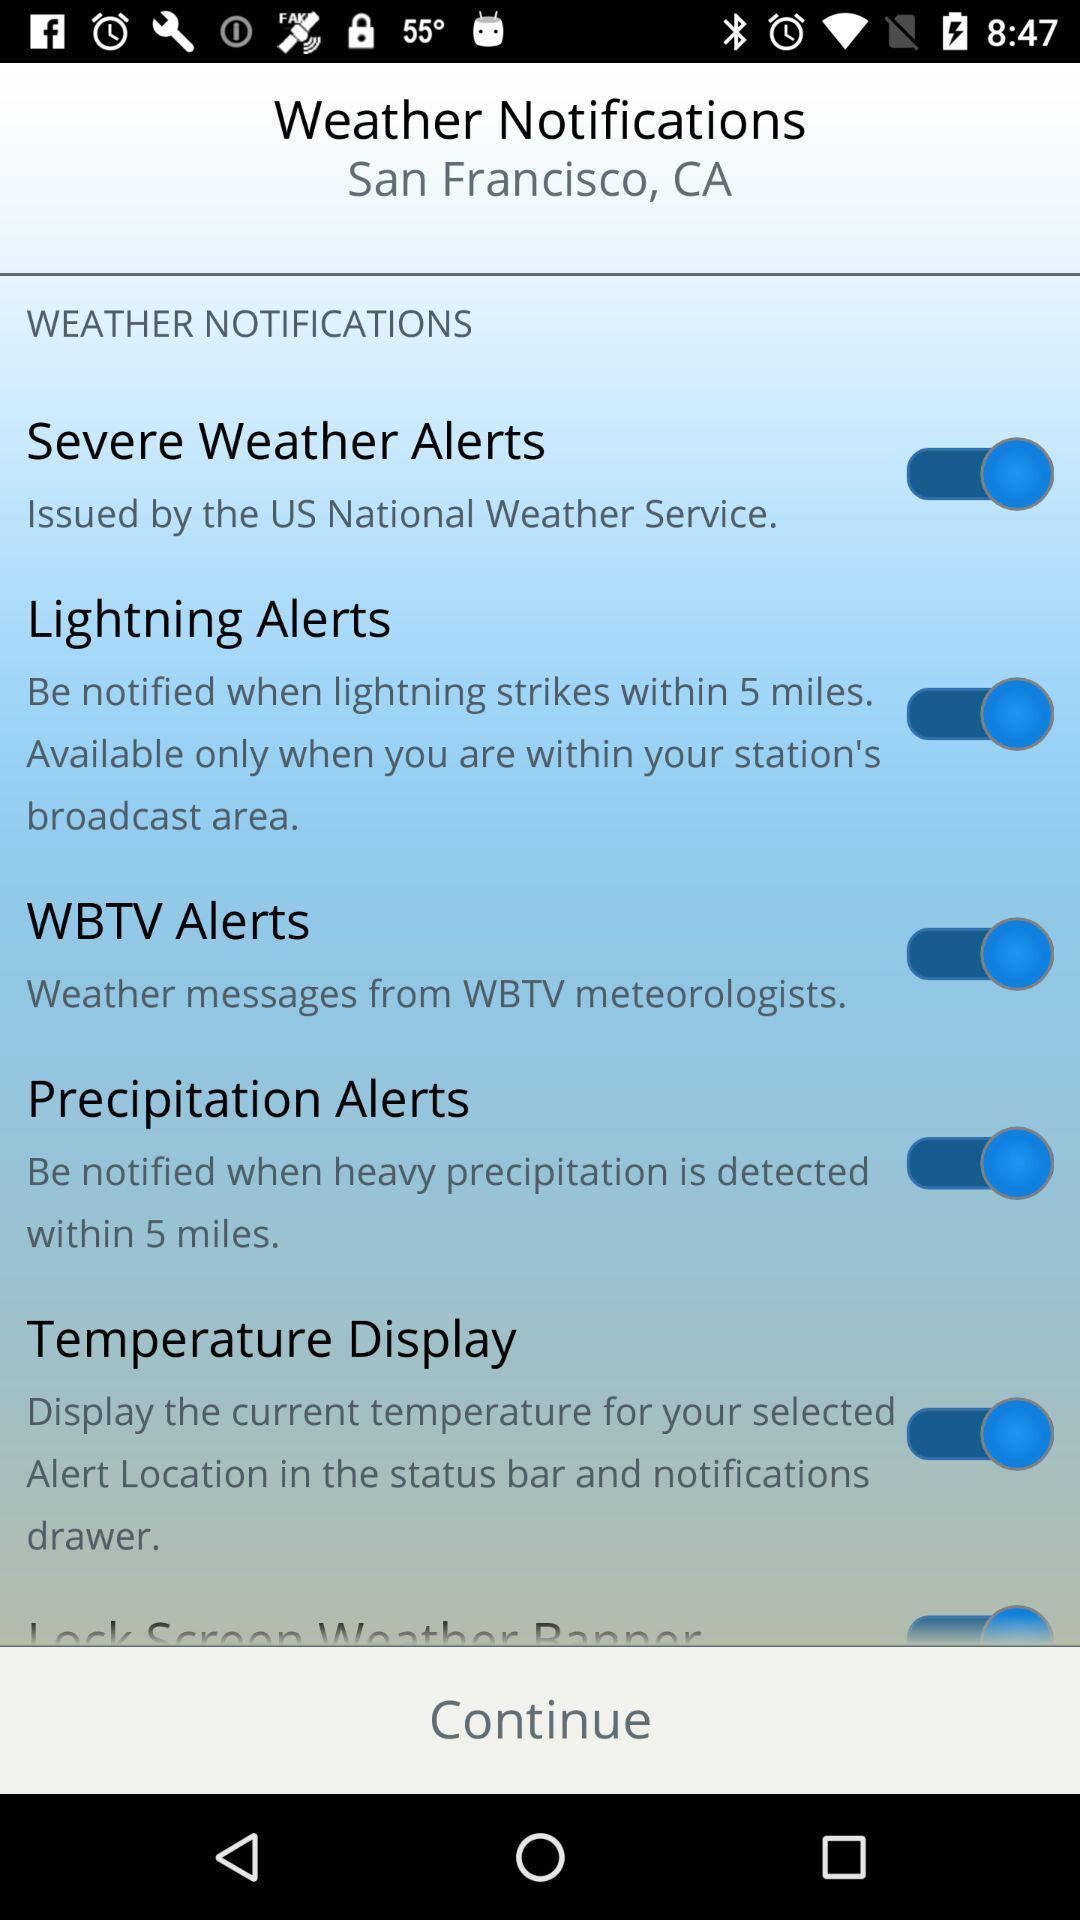What is the status of the "Precipitation Alerts"? The status is "on". 